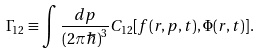<formula> <loc_0><loc_0><loc_500><loc_500>\Gamma _ { 1 2 } \equiv \int \frac { d { p } } { ( 2 \pi \hbar { ) } ^ { 3 } } C _ { 1 2 } [ f ( { r } , { p } , t ) , \Phi ( { r } , t ) ] .</formula> 